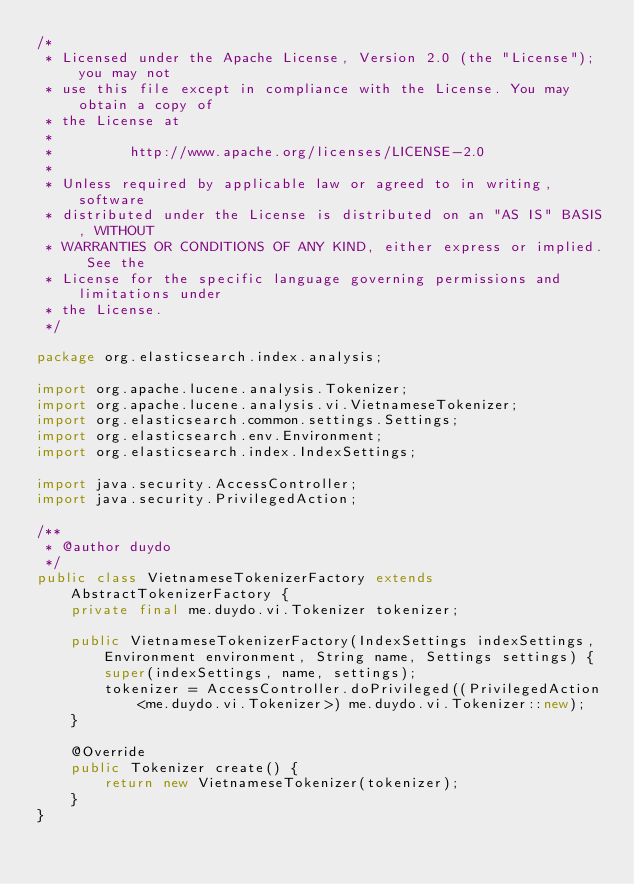Convert code to text. <code><loc_0><loc_0><loc_500><loc_500><_Java_>/*
 * Licensed under the Apache License, Version 2.0 (the "License"); you may not
 * use this file except in compliance with the License. You may obtain a copy of
 * the License at
 *
 *         http://www.apache.org/licenses/LICENSE-2.0
 *
 * Unless required by applicable law or agreed to in writing, software
 * distributed under the License is distributed on an "AS IS" BASIS, WITHOUT
 * WARRANTIES OR CONDITIONS OF ANY KIND, either express or implied. See the
 * License for the specific language governing permissions and limitations under
 * the License.
 */

package org.elasticsearch.index.analysis;

import org.apache.lucene.analysis.Tokenizer;
import org.apache.lucene.analysis.vi.VietnameseTokenizer;
import org.elasticsearch.common.settings.Settings;
import org.elasticsearch.env.Environment;
import org.elasticsearch.index.IndexSettings;

import java.security.AccessController;
import java.security.PrivilegedAction;

/**
 * @author duydo
 */
public class VietnameseTokenizerFactory extends AbstractTokenizerFactory {
    private final me.duydo.vi.Tokenizer tokenizer;

    public VietnameseTokenizerFactory(IndexSettings indexSettings, Environment environment, String name, Settings settings) {
        super(indexSettings, name, settings);
        tokenizer = AccessController.doPrivileged((PrivilegedAction<me.duydo.vi.Tokenizer>) me.duydo.vi.Tokenizer::new);
    }

    @Override
    public Tokenizer create() {
        return new VietnameseTokenizer(tokenizer);
    }
}
</code> 